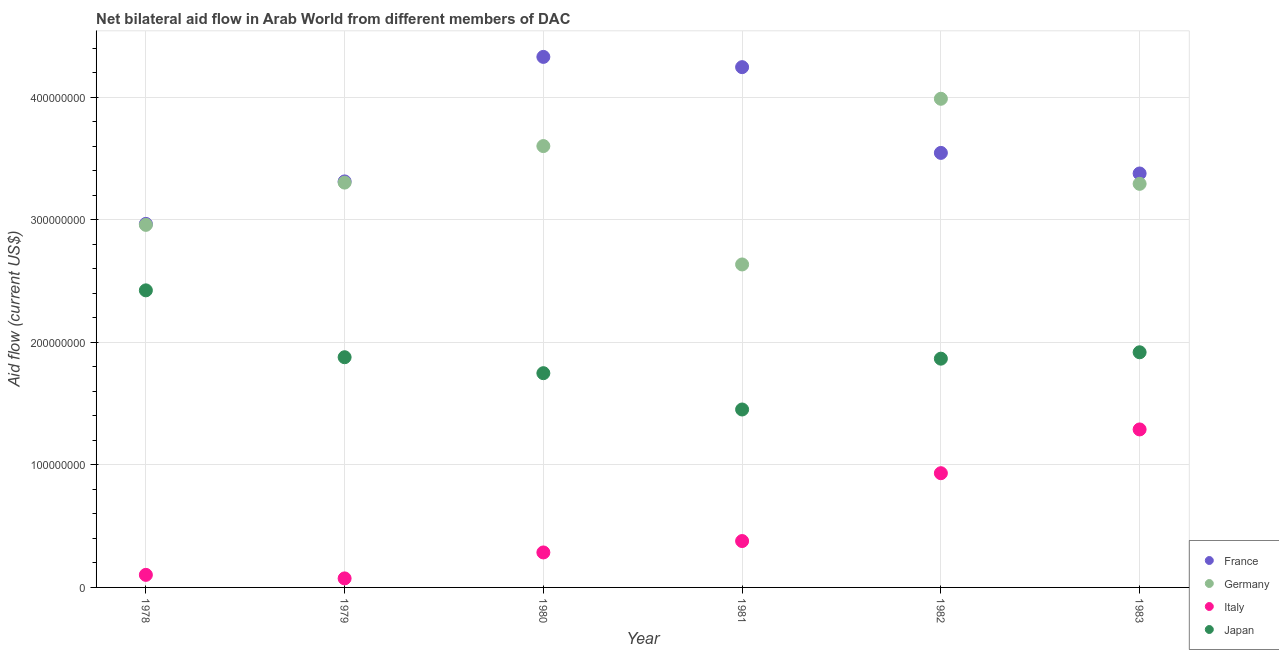How many different coloured dotlines are there?
Provide a short and direct response. 4. What is the amount of aid given by france in 1981?
Provide a succinct answer. 4.25e+08. Across all years, what is the maximum amount of aid given by france?
Your answer should be very brief. 4.33e+08. Across all years, what is the minimum amount of aid given by italy?
Your answer should be compact. 7.37e+06. In which year was the amount of aid given by germany maximum?
Keep it short and to the point. 1982. In which year was the amount of aid given by france minimum?
Provide a succinct answer. 1978. What is the total amount of aid given by japan in the graph?
Make the answer very short. 1.13e+09. What is the difference between the amount of aid given by france in 1978 and that in 1981?
Provide a succinct answer. -1.28e+08. What is the difference between the amount of aid given by japan in 1979 and the amount of aid given by germany in 1983?
Your response must be concise. -1.41e+08. What is the average amount of aid given by italy per year?
Make the answer very short. 5.10e+07. In the year 1980, what is the difference between the amount of aid given by japan and amount of aid given by italy?
Provide a succinct answer. 1.46e+08. In how many years, is the amount of aid given by japan greater than 340000000 US$?
Make the answer very short. 0. What is the ratio of the amount of aid given by italy in 1980 to that in 1982?
Make the answer very short. 0.31. Is the difference between the amount of aid given by italy in 1980 and 1982 greater than the difference between the amount of aid given by france in 1980 and 1982?
Ensure brevity in your answer.  No. What is the difference between the highest and the second highest amount of aid given by germany?
Give a very brief answer. 3.86e+07. What is the difference between the highest and the lowest amount of aid given by italy?
Ensure brevity in your answer.  1.22e+08. In how many years, is the amount of aid given by france greater than the average amount of aid given by france taken over all years?
Your answer should be very brief. 2. Is it the case that in every year, the sum of the amount of aid given by france and amount of aid given by germany is greater than the amount of aid given by italy?
Your response must be concise. Yes. Does the amount of aid given by japan monotonically increase over the years?
Offer a very short reply. No. Is the amount of aid given by italy strictly greater than the amount of aid given by germany over the years?
Your answer should be compact. No. How many dotlines are there?
Your response must be concise. 4. How many years are there in the graph?
Ensure brevity in your answer.  6. Are the values on the major ticks of Y-axis written in scientific E-notation?
Make the answer very short. No. How many legend labels are there?
Make the answer very short. 4. What is the title of the graph?
Give a very brief answer. Net bilateral aid flow in Arab World from different members of DAC. What is the label or title of the Y-axis?
Make the answer very short. Aid flow (current US$). What is the Aid flow (current US$) of France in 1978?
Make the answer very short. 2.97e+08. What is the Aid flow (current US$) of Germany in 1978?
Your answer should be compact. 2.96e+08. What is the Aid flow (current US$) of Italy in 1978?
Your answer should be compact. 1.02e+07. What is the Aid flow (current US$) in Japan in 1978?
Offer a terse response. 2.42e+08. What is the Aid flow (current US$) in France in 1979?
Give a very brief answer. 3.31e+08. What is the Aid flow (current US$) of Germany in 1979?
Your answer should be very brief. 3.30e+08. What is the Aid flow (current US$) of Italy in 1979?
Give a very brief answer. 7.37e+06. What is the Aid flow (current US$) in Japan in 1979?
Give a very brief answer. 1.88e+08. What is the Aid flow (current US$) in France in 1980?
Offer a terse response. 4.33e+08. What is the Aid flow (current US$) of Germany in 1980?
Your answer should be compact. 3.60e+08. What is the Aid flow (current US$) in Italy in 1980?
Your response must be concise. 2.85e+07. What is the Aid flow (current US$) of Japan in 1980?
Make the answer very short. 1.75e+08. What is the Aid flow (current US$) in France in 1981?
Provide a succinct answer. 4.25e+08. What is the Aid flow (current US$) of Germany in 1981?
Make the answer very short. 2.64e+08. What is the Aid flow (current US$) in Italy in 1981?
Provide a short and direct response. 3.78e+07. What is the Aid flow (current US$) in Japan in 1981?
Make the answer very short. 1.45e+08. What is the Aid flow (current US$) in France in 1982?
Your answer should be compact. 3.55e+08. What is the Aid flow (current US$) of Germany in 1982?
Ensure brevity in your answer.  3.99e+08. What is the Aid flow (current US$) of Italy in 1982?
Your response must be concise. 9.32e+07. What is the Aid flow (current US$) of Japan in 1982?
Your answer should be very brief. 1.87e+08. What is the Aid flow (current US$) of France in 1983?
Your answer should be very brief. 3.38e+08. What is the Aid flow (current US$) of Germany in 1983?
Offer a terse response. 3.29e+08. What is the Aid flow (current US$) of Italy in 1983?
Offer a very short reply. 1.29e+08. What is the Aid flow (current US$) in Japan in 1983?
Make the answer very short. 1.92e+08. Across all years, what is the maximum Aid flow (current US$) in France?
Offer a terse response. 4.33e+08. Across all years, what is the maximum Aid flow (current US$) of Germany?
Offer a very short reply. 3.99e+08. Across all years, what is the maximum Aid flow (current US$) of Italy?
Offer a very short reply. 1.29e+08. Across all years, what is the maximum Aid flow (current US$) of Japan?
Your answer should be compact. 2.42e+08. Across all years, what is the minimum Aid flow (current US$) in France?
Your response must be concise. 2.97e+08. Across all years, what is the minimum Aid flow (current US$) of Germany?
Your response must be concise. 2.64e+08. Across all years, what is the minimum Aid flow (current US$) of Italy?
Make the answer very short. 7.37e+06. Across all years, what is the minimum Aid flow (current US$) in Japan?
Provide a succinct answer. 1.45e+08. What is the total Aid flow (current US$) of France in the graph?
Provide a short and direct response. 2.18e+09. What is the total Aid flow (current US$) of Germany in the graph?
Make the answer very short. 1.98e+09. What is the total Aid flow (current US$) in Italy in the graph?
Give a very brief answer. 3.06e+08. What is the total Aid flow (current US$) in Japan in the graph?
Give a very brief answer. 1.13e+09. What is the difference between the Aid flow (current US$) of France in 1978 and that in 1979?
Provide a short and direct response. -3.47e+07. What is the difference between the Aid flow (current US$) in Germany in 1978 and that in 1979?
Ensure brevity in your answer.  -3.45e+07. What is the difference between the Aid flow (current US$) in Italy in 1978 and that in 1979?
Your answer should be very brief. 2.88e+06. What is the difference between the Aid flow (current US$) of Japan in 1978 and that in 1979?
Your answer should be compact. 5.46e+07. What is the difference between the Aid flow (current US$) of France in 1978 and that in 1980?
Offer a terse response. -1.36e+08. What is the difference between the Aid flow (current US$) of Germany in 1978 and that in 1980?
Offer a terse response. -6.43e+07. What is the difference between the Aid flow (current US$) of Italy in 1978 and that in 1980?
Offer a terse response. -1.83e+07. What is the difference between the Aid flow (current US$) of Japan in 1978 and that in 1980?
Your answer should be compact. 6.76e+07. What is the difference between the Aid flow (current US$) in France in 1978 and that in 1981?
Ensure brevity in your answer.  -1.28e+08. What is the difference between the Aid flow (current US$) in Germany in 1978 and that in 1981?
Offer a very short reply. 3.23e+07. What is the difference between the Aid flow (current US$) of Italy in 1978 and that in 1981?
Keep it short and to the point. -2.76e+07. What is the difference between the Aid flow (current US$) of Japan in 1978 and that in 1981?
Your response must be concise. 9.72e+07. What is the difference between the Aid flow (current US$) of France in 1978 and that in 1982?
Offer a very short reply. -5.79e+07. What is the difference between the Aid flow (current US$) of Germany in 1978 and that in 1982?
Provide a succinct answer. -1.03e+08. What is the difference between the Aid flow (current US$) in Italy in 1978 and that in 1982?
Keep it short and to the point. -8.30e+07. What is the difference between the Aid flow (current US$) of Japan in 1978 and that in 1982?
Keep it short and to the point. 5.57e+07. What is the difference between the Aid flow (current US$) of France in 1978 and that in 1983?
Offer a very short reply. -4.11e+07. What is the difference between the Aid flow (current US$) of Germany in 1978 and that in 1983?
Provide a short and direct response. -3.35e+07. What is the difference between the Aid flow (current US$) in Italy in 1978 and that in 1983?
Offer a terse response. -1.19e+08. What is the difference between the Aid flow (current US$) in Japan in 1978 and that in 1983?
Offer a very short reply. 5.05e+07. What is the difference between the Aid flow (current US$) in France in 1979 and that in 1980?
Provide a short and direct response. -1.02e+08. What is the difference between the Aid flow (current US$) in Germany in 1979 and that in 1980?
Make the answer very short. -2.98e+07. What is the difference between the Aid flow (current US$) of Italy in 1979 and that in 1980?
Provide a short and direct response. -2.12e+07. What is the difference between the Aid flow (current US$) in Japan in 1979 and that in 1980?
Give a very brief answer. 1.30e+07. What is the difference between the Aid flow (current US$) of France in 1979 and that in 1981?
Your response must be concise. -9.32e+07. What is the difference between the Aid flow (current US$) in Germany in 1979 and that in 1981?
Your response must be concise. 6.68e+07. What is the difference between the Aid flow (current US$) in Italy in 1979 and that in 1981?
Provide a short and direct response. -3.05e+07. What is the difference between the Aid flow (current US$) in Japan in 1979 and that in 1981?
Your answer should be very brief. 4.26e+07. What is the difference between the Aid flow (current US$) in France in 1979 and that in 1982?
Provide a short and direct response. -2.33e+07. What is the difference between the Aid flow (current US$) of Germany in 1979 and that in 1982?
Your answer should be compact. -6.84e+07. What is the difference between the Aid flow (current US$) of Italy in 1979 and that in 1982?
Give a very brief answer. -8.58e+07. What is the difference between the Aid flow (current US$) of Japan in 1979 and that in 1982?
Offer a very short reply. 1.18e+06. What is the difference between the Aid flow (current US$) in France in 1979 and that in 1983?
Give a very brief answer. -6.48e+06. What is the difference between the Aid flow (current US$) of Germany in 1979 and that in 1983?
Offer a very short reply. 1.01e+06. What is the difference between the Aid flow (current US$) of Italy in 1979 and that in 1983?
Provide a short and direct response. -1.22e+08. What is the difference between the Aid flow (current US$) of Japan in 1979 and that in 1983?
Your answer should be very brief. -4.03e+06. What is the difference between the Aid flow (current US$) in France in 1980 and that in 1981?
Make the answer very short. 8.36e+06. What is the difference between the Aid flow (current US$) of Germany in 1980 and that in 1981?
Keep it short and to the point. 9.66e+07. What is the difference between the Aid flow (current US$) of Italy in 1980 and that in 1981?
Keep it short and to the point. -9.30e+06. What is the difference between the Aid flow (current US$) of Japan in 1980 and that in 1981?
Make the answer very short. 2.96e+07. What is the difference between the Aid flow (current US$) in France in 1980 and that in 1982?
Your answer should be compact. 7.83e+07. What is the difference between the Aid flow (current US$) of Germany in 1980 and that in 1982?
Keep it short and to the point. -3.86e+07. What is the difference between the Aid flow (current US$) of Italy in 1980 and that in 1982?
Provide a succinct answer. -6.47e+07. What is the difference between the Aid flow (current US$) of Japan in 1980 and that in 1982?
Provide a succinct answer. -1.18e+07. What is the difference between the Aid flow (current US$) in France in 1980 and that in 1983?
Your answer should be very brief. 9.51e+07. What is the difference between the Aid flow (current US$) in Germany in 1980 and that in 1983?
Make the answer very short. 3.08e+07. What is the difference between the Aid flow (current US$) in Italy in 1980 and that in 1983?
Your response must be concise. -1.00e+08. What is the difference between the Aid flow (current US$) in Japan in 1980 and that in 1983?
Your answer should be compact. -1.70e+07. What is the difference between the Aid flow (current US$) in France in 1981 and that in 1982?
Offer a terse response. 7.00e+07. What is the difference between the Aid flow (current US$) of Germany in 1981 and that in 1982?
Offer a very short reply. -1.35e+08. What is the difference between the Aid flow (current US$) in Italy in 1981 and that in 1982?
Ensure brevity in your answer.  -5.54e+07. What is the difference between the Aid flow (current US$) of Japan in 1981 and that in 1982?
Offer a very short reply. -4.15e+07. What is the difference between the Aid flow (current US$) in France in 1981 and that in 1983?
Provide a short and direct response. 8.68e+07. What is the difference between the Aid flow (current US$) of Germany in 1981 and that in 1983?
Provide a short and direct response. -6.58e+07. What is the difference between the Aid flow (current US$) of Italy in 1981 and that in 1983?
Provide a succinct answer. -9.11e+07. What is the difference between the Aid flow (current US$) in Japan in 1981 and that in 1983?
Provide a succinct answer. -4.67e+07. What is the difference between the Aid flow (current US$) of France in 1982 and that in 1983?
Offer a very short reply. 1.68e+07. What is the difference between the Aid flow (current US$) in Germany in 1982 and that in 1983?
Your response must be concise. 6.94e+07. What is the difference between the Aid flow (current US$) in Italy in 1982 and that in 1983?
Offer a very short reply. -3.57e+07. What is the difference between the Aid flow (current US$) of Japan in 1982 and that in 1983?
Your response must be concise. -5.21e+06. What is the difference between the Aid flow (current US$) in France in 1978 and the Aid flow (current US$) in Germany in 1979?
Ensure brevity in your answer.  -3.37e+07. What is the difference between the Aid flow (current US$) of France in 1978 and the Aid flow (current US$) of Italy in 1979?
Offer a very short reply. 2.89e+08. What is the difference between the Aid flow (current US$) in France in 1978 and the Aid flow (current US$) in Japan in 1979?
Make the answer very short. 1.09e+08. What is the difference between the Aid flow (current US$) in Germany in 1978 and the Aid flow (current US$) in Italy in 1979?
Ensure brevity in your answer.  2.88e+08. What is the difference between the Aid flow (current US$) of Germany in 1978 and the Aid flow (current US$) of Japan in 1979?
Your answer should be very brief. 1.08e+08. What is the difference between the Aid flow (current US$) in Italy in 1978 and the Aid flow (current US$) in Japan in 1979?
Keep it short and to the point. -1.78e+08. What is the difference between the Aid flow (current US$) in France in 1978 and the Aid flow (current US$) in Germany in 1980?
Offer a very short reply. -6.35e+07. What is the difference between the Aid flow (current US$) in France in 1978 and the Aid flow (current US$) in Italy in 1980?
Give a very brief answer. 2.68e+08. What is the difference between the Aid flow (current US$) of France in 1978 and the Aid flow (current US$) of Japan in 1980?
Give a very brief answer. 1.22e+08. What is the difference between the Aid flow (current US$) of Germany in 1978 and the Aid flow (current US$) of Italy in 1980?
Your answer should be compact. 2.67e+08. What is the difference between the Aid flow (current US$) in Germany in 1978 and the Aid flow (current US$) in Japan in 1980?
Provide a short and direct response. 1.21e+08. What is the difference between the Aid flow (current US$) in Italy in 1978 and the Aid flow (current US$) in Japan in 1980?
Offer a very short reply. -1.65e+08. What is the difference between the Aid flow (current US$) of France in 1978 and the Aid flow (current US$) of Germany in 1981?
Provide a short and direct response. 3.31e+07. What is the difference between the Aid flow (current US$) in France in 1978 and the Aid flow (current US$) in Italy in 1981?
Keep it short and to the point. 2.59e+08. What is the difference between the Aid flow (current US$) in France in 1978 and the Aid flow (current US$) in Japan in 1981?
Make the answer very short. 1.51e+08. What is the difference between the Aid flow (current US$) of Germany in 1978 and the Aid flow (current US$) of Italy in 1981?
Your answer should be very brief. 2.58e+08. What is the difference between the Aid flow (current US$) in Germany in 1978 and the Aid flow (current US$) in Japan in 1981?
Ensure brevity in your answer.  1.51e+08. What is the difference between the Aid flow (current US$) of Italy in 1978 and the Aid flow (current US$) of Japan in 1981?
Keep it short and to the point. -1.35e+08. What is the difference between the Aid flow (current US$) of France in 1978 and the Aid flow (current US$) of Germany in 1982?
Ensure brevity in your answer.  -1.02e+08. What is the difference between the Aid flow (current US$) in France in 1978 and the Aid flow (current US$) in Italy in 1982?
Give a very brief answer. 2.03e+08. What is the difference between the Aid flow (current US$) in France in 1978 and the Aid flow (current US$) in Japan in 1982?
Your answer should be compact. 1.10e+08. What is the difference between the Aid flow (current US$) of Germany in 1978 and the Aid flow (current US$) of Italy in 1982?
Offer a very short reply. 2.03e+08. What is the difference between the Aid flow (current US$) in Germany in 1978 and the Aid flow (current US$) in Japan in 1982?
Keep it short and to the point. 1.09e+08. What is the difference between the Aid flow (current US$) in Italy in 1978 and the Aid flow (current US$) in Japan in 1982?
Give a very brief answer. -1.76e+08. What is the difference between the Aid flow (current US$) in France in 1978 and the Aid flow (current US$) in Germany in 1983?
Give a very brief answer. -3.27e+07. What is the difference between the Aid flow (current US$) in France in 1978 and the Aid flow (current US$) in Italy in 1983?
Offer a terse response. 1.68e+08. What is the difference between the Aid flow (current US$) of France in 1978 and the Aid flow (current US$) of Japan in 1983?
Make the answer very short. 1.05e+08. What is the difference between the Aid flow (current US$) of Germany in 1978 and the Aid flow (current US$) of Italy in 1983?
Give a very brief answer. 1.67e+08. What is the difference between the Aid flow (current US$) of Germany in 1978 and the Aid flow (current US$) of Japan in 1983?
Your answer should be compact. 1.04e+08. What is the difference between the Aid flow (current US$) of Italy in 1978 and the Aid flow (current US$) of Japan in 1983?
Give a very brief answer. -1.82e+08. What is the difference between the Aid flow (current US$) of France in 1979 and the Aid flow (current US$) of Germany in 1980?
Make the answer very short. -2.88e+07. What is the difference between the Aid flow (current US$) in France in 1979 and the Aid flow (current US$) in Italy in 1980?
Make the answer very short. 3.03e+08. What is the difference between the Aid flow (current US$) in France in 1979 and the Aid flow (current US$) in Japan in 1980?
Your answer should be very brief. 1.56e+08. What is the difference between the Aid flow (current US$) in Germany in 1979 and the Aid flow (current US$) in Italy in 1980?
Offer a terse response. 3.02e+08. What is the difference between the Aid flow (current US$) of Germany in 1979 and the Aid flow (current US$) of Japan in 1980?
Give a very brief answer. 1.56e+08. What is the difference between the Aid flow (current US$) of Italy in 1979 and the Aid flow (current US$) of Japan in 1980?
Your response must be concise. -1.67e+08. What is the difference between the Aid flow (current US$) of France in 1979 and the Aid flow (current US$) of Germany in 1981?
Offer a very short reply. 6.78e+07. What is the difference between the Aid flow (current US$) of France in 1979 and the Aid flow (current US$) of Italy in 1981?
Ensure brevity in your answer.  2.93e+08. What is the difference between the Aid flow (current US$) of France in 1979 and the Aid flow (current US$) of Japan in 1981?
Provide a succinct answer. 1.86e+08. What is the difference between the Aid flow (current US$) in Germany in 1979 and the Aid flow (current US$) in Italy in 1981?
Keep it short and to the point. 2.92e+08. What is the difference between the Aid flow (current US$) of Germany in 1979 and the Aid flow (current US$) of Japan in 1981?
Provide a succinct answer. 1.85e+08. What is the difference between the Aid flow (current US$) in Italy in 1979 and the Aid flow (current US$) in Japan in 1981?
Offer a terse response. -1.38e+08. What is the difference between the Aid flow (current US$) of France in 1979 and the Aid flow (current US$) of Germany in 1982?
Give a very brief answer. -6.74e+07. What is the difference between the Aid flow (current US$) of France in 1979 and the Aid flow (current US$) of Italy in 1982?
Your response must be concise. 2.38e+08. What is the difference between the Aid flow (current US$) in France in 1979 and the Aid flow (current US$) in Japan in 1982?
Your response must be concise. 1.45e+08. What is the difference between the Aid flow (current US$) of Germany in 1979 and the Aid flow (current US$) of Italy in 1982?
Your answer should be very brief. 2.37e+08. What is the difference between the Aid flow (current US$) of Germany in 1979 and the Aid flow (current US$) of Japan in 1982?
Keep it short and to the point. 1.44e+08. What is the difference between the Aid flow (current US$) in Italy in 1979 and the Aid flow (current US$) in Japan in 1982?
Your answer should be compact. -1.79e+08. What is the difference between the Aid flow (current US$) of France in 1979 and the Aid flow (current US$) of Germany in 1983?
Keep it short and to the point. 1.97e+06. What is the difference between the Aid flow (current US$) in France in 1979 and the Aid flow (current US$) in Italy in 1983?
Provide a short and direct response. 2.02e+08. What is the difference between the Aid flow (current US$) of France in 1979 and the Aid flow (current US$) of Japan in 1983?
Give a very brief answer. 1.39e+08. What is the difference between the Aid flow (current US$) in Germany in 1979 and the Aid flow (current US$) in Italy in 1983?
Give a very brief answer. 2.01e+08. What is the difference between the Aid flow (current US$) of Germany in 1979 and the Aid flow (current US$) of Japan in 1983?
Ensure brevity in your answer.  1.38e+08. What is the difference between the Aid flow (current US$) of Italy in 1979 and the Aid flow (current US$) of Japan in 1983?
Your answer should be very brief. -1.84e+08. What is the difference between the Aid flow (current US$) in France in 1980 and the Aid flow (current US$) in Germany in 1981?
Your answer should be very brief. 1.69e+08. What is the difference between the Aid flow (current US$) in France in 1980 and the Aid flow (current US$) in Italy in 1981?
Offer a terse response. 3.95e+08. What is the difference between the Aid flow (current US$) in France in 1980 and the Aid flow (current US$) in Japan in 1981?
Give a very brief answer. 2.88e+08. What is the difference between the Aid flow (current US$) in Germany in 1980 and the Aid flow (current US$) in Italy in 1981?
Your answer should be very brief. 3.22e+08. What is the difference between the Aid flow (current US$) in Germany in 1980 and the Aid flow (current US$) in Japan in 1981?
Offer a very short reply. 2.15e+08. What is the difference between the Aid flow (current US$) in Italy in 1980 and the Aid flow (current US$) in Japan in 1981?
Provide a short and direct response. -1.17e+08. What is the difference between the Aid flow (current US$) in France in 1980 and the Aid flow (current US$) in Germany in 1982?
Ensure brevity in your answer.  3.42e+07. What is the difference between the Aid flow (current US$) of France in 1980 and the Aid flow (current US$) of Italy in 1982?
Offer a terse response. 3.40e+08. What is the difference between the Aid flow (current US$) in France in 1980 and the Aid flow (current US$) in Japan in 1982?
Your answer should be very brief. 2.46e+08. What is the difference between the Aid flow (current US$) in Germany in 1980 and the Aid flow (current US$) in Italy in 1982?
Keep it short and to the point. 2.67e+08. What is the difference between the Aid flow (current US$) in Germany in 1980 and the Aid flow (current US$) in Japan in 1982?
Give a very brief answer. 1.73e+08. What is the difference between the Aid flow (current US$) in Italy in 1980 and the Aid flow (current US$) in Japan in 1982?
Your response must be concise. -1.58e+08. What is the difference between the Aid flow (current US$) in France in 1980 and the Aid flow (current US$) in Germany in 1983?
Offer a terse response. 1.04e+08. What is the difference between the Aid flow (current US$) in France in 1980 and the Aid flow (current US$) in Italy in 1983?
Provide a short and direct response. 3.04e+08. What is the difference between the Aid flow (current US$) in France in 1980 and the Aid flow (current US$) in Japan in 1983?
Make the answer very short. 2.41e+08. What is the difference between the Aid flow (current US$) of Germany in 1980 and the Aid flow (current US$) of Italy in 1983?
Ensure brevity in your answer.  2.31e+08. What is the difference between the Aid flow (current US$) of Germany in 1980 and the Aid flow (current US$) of Japan in 1983?
Provide a succinct answer. 1.68e+08. What is the difference between the Aid flow (current US$) in Italy in 1980 and the Aid flow (current US$) in Japan in 1983?
Keep it short and to the point. -1.63e+08. What is the difference between the Aid flow (current US$) in France in 1981 and the Aid flow (current US$) in Germany in 1982?
Make the answer very short. 2.58e+07. What is the difference between the Aid flow (current US$) in France in 1981 and the Aid flow (current US$) in Italy in 1982?
Offer a terse response. 3.31e+08. What is the difference between the Aid flow (current US$) of France in 1981 and the Aid flow (current US$) of Japan in 1982?
Give a very brief answer. 2.38e+08. What is the difference between the Aid flow (current US$) in Germany in 1981 and the Aid flow (current US$) in Italy in 1982?
Offer a very short reply. 1.70e+08. What is the difference between the Aid flow (current US$) of Germany in 1981 and the Aid flow (current US$) of Japan in 1982?
Your answer should be compact. 7.69e+07. What is the difference between the Aid flow (current US$) in Italy in 1981 and the Aid flow (current US$) in Japan in 1982?
Offer a very short reply. -1.49e+08. What is the difference between the Aid flow (current US$) in France in 1981 and the Aid flow (current US$) in Germany in 1983?
Offer a terse response. 9.52e+07. What is the difference between the Aid flow (current US$) of France in 1981 and the Aid flow (current US$) of Italy in 1983?
Your answer should be compact. 2.96e+08. What is the difference between the Aid flow (current US$) in France in 1981 and the Aid flow (current US$) in Japan in 1983?
Provide a short and direct response. 2.33e+08. What is the difference between the Aid flow (current US$) in Germany in 1981 and the Aid flow (current US$) in Italy in 1983?
Your answer should be compact. 1.35e+08. What is the difference between the Aid flow (current US$) in Germany in 1981 and the Aid flow (current US$) in Japan in 1983?
Your response must be concise. 7.17e+07. What is the difference between the Aid flow (current US$) in Italy in 1981 and the Aid flow (current US$) in Japan in 1983?
Provide a succinct answer. -1.54e+08. What is the difference between the Aid flow (current US$) in France in 1982 and the Aid flow (current US$) in Germany in 1983?
Provide a succinct answer. 2.52e+07. What is the difference between the Aid flow (current US$) in France in 1982 and the Aid flow (current US$) in Italy in 1983?
Offer a very short reply. 2.26e+08. What is the difference between the Aid flow (current US$) of France in 1982 and the Aid flow (current US$) of Japan in 1983?
Make the answer very short. 1.63e+08. What is the difference between the Aid flow (current US$) of Germany in 1982 and the Aid flow (current US$) of Italy in 1983?
Provide a succinct answer. 2.70e+08. What is the difference between the Aid flow (current US$) in Germany in 1982 and the Aid flow (current US$) in Japan in 1983?
Offer a very short reply. 2.07e+08. What is the difference between the Aid flow (current US$) of Italy in 1982 and the Aid flow (current US$) of Japan in 1983?
Your answer should be compact. -9.87e+07. What is the average Aid flow (current US$) of France per year?
Offer a terse response. 3.63e+08. What is the average Aid flow (current US$) in Germany per year?
Provide a succinct answer. 3.30e+08. What is the average Aid flow (current US$) in Italy per year?
Provide a succinct answer. 5.10e+07. What is the average Aid flow (current US$) of Japan per year?
Keep it short and to the point. 1.88e+08. In the year 1978, what is the difference between the Aid flow (current US$) in France and Aid flow (current US$) in Germany?
Make the answer very short. 7.90e+05. In the year 1978, what is the difference between the Aid flow (current US$) in France and Aid flow (current US$) in Italy?
Provide a short and direct response. 2.86e+08. In the year 1978, what is the difference between the Aid flow (current US$) of France and Aid flow (current US$) of Japan?
Give a very brief answer. 5.42e+07. In the year 1978, what is the difference between the Aid flow (current US$) of Germany and Aid flow (current US$) of Italy?
Your answer should be compact. 2.86e+08. In the year 1978, what is the difference between the Aid flow (current US$) of Germany and Aid flow (current US$) of Japan?
Offer a very short reply. 5.34e+07. In the year 1978, what is the difference between the Aid flow (current US$) in Italy and Aid flow (current US$) in Japan?
Offer a terse response. -2.32e+08. In the year 1979, what is the difference between the Aid flow (current US$) of France and Aid flow (current US$) of Germany?
Provide a short and direct response. 9.60e+05. In the year 1979, what is the difference between the Aid flow (current US$) in France and Aid flow (current US$) in Italy?
Your answer should be compact. 3.24e+08. In the year 1979, what is the difference between the Aid flow (current US$) of France and Aid flow (current US$) of Japan?
Keep it short and to the point. 1.43e+08. In the year 1979, what is the difference between the Aid flow (current US$) in Germany and Aid flow (current US$) in Italy?
Provide a short and direct response. 3.23e+08. In the year 1979, what is the difference between the Aid flow (current US$) in Germany and Aid flow (current US$) in Japan?
Ensure brevity in your answer.  1.42e+08. In the year 1979, what is the difference between the Aid flow (current US$) of Italy and Aid flow (current US$) of Japan?
Make the answer very short. -1.80e+08. In the year 1980, what is the difference between the Aid flow (current US$) of France and Aid flow (current US$) of Germany?
Keep it short and to the point. 7.28e+07. In the year 1980, what is the difference between the Aid flow (current US$) of France and Aid flow (current US$) of Italy?
Offer a terse response. 4.04e+08. In the year 1980, what is the difference between the Aid flow (current US$) of France and Aid flow (current US$) of Japan?
Provide a succinct answer. 2.58e+08. In the year 1980, what is the difference between the Aid flow (current US$) of Germany and Aid flow (current US$) of Italy?
Your response must be concise. 3.32e+08. In the year 1980, what is the difference between the Aid flow (current US$) of Germany and Aid flow (current US$) of Japan?
Provide a succinct answer. 1.85e+08. In the year 1980, what is the difference between the Aid flow (current US$) in Italy and Aid flow (current US$) in Japan?
Your answer should be very brief. -1.46e+08. In the year 1981, what is the difference between the Aid flow (current US$) in France and Aid flow (current US$) in Germany?
Your answer should be compact. 1.61e+08. In the year 1981, what is the difference between the Aid flow (current US$) in France and Aid flow (current US$) in Italy?
Provide a succinct answer. 3.87e+08. In the year 1981, what is the difference between the Aid flow (current US$) of France and Aid flow (current US$) of Japan?
Provide a succinct answer. 2.79e+08. In the year 1981, what is the difference between the Aid flow (current US$) of Germany and Aid flow (current US$) of Italy?
Make the answer very short. 2.26e+08. In the year 1981, what is the difference between the Aid flow (current US$) of Germany and Aid flow (current US$) of Japan?
Ensure brevity in your answer.  1.18e+08. In the year 1981, what is the difference between the Aid flow (current US$) of Italy and Aid flow (current US$) of Japan?
Offer a very short reply. -1.07e+08. In the year 1982, what is the difference between the Aid flow (current US$) of France and Aid flow (current US$) of Germany?
Offer a very short reply. -4.42e+07. In the year 1982, what is the difference between the Aid flow (current US$) in France and Aid flow (current US$) in Italy?
Provide a succinct answer. 2.61e+08. In the year 1982, what is the difference between the Aid flow (current US$) of France and Aid flow (current US$) of Japan?
Make the answer very short. 1.68e+08. In the year 1982, what is the difference between the Aid flow (current US$) in Germany and Aid flow (current US$) in Italy?
Make the answer very short. 3.06e+08. In the year 1982, what is the difference between the Aid flow (current US$) of Germany and Aid flow (current US$) of Japan?
Provide a short and direct response. 2.12e+08. In the year 1982, what is the difference between the Aid flow (current US$) of Italy and Aid flow (current US$) of Japan?
Offer a terse response. -9.34e+07. In the year 1983, what is the difference between the Aid flow (current US$) in France and Aid flow (current US$) in Germany?
Offer a very short reply. 8.45e+06. In the year 1983, what is the difference between the Aid flow (current US$) of France and Aid flow (current US$) of Italy?
Provide a short and direct response. 2.09e+08. In the year 1983, what is the difference between the Aid flow (current US$) of France and Aid flow (current US$) of Japan?
Keep it short and to the point. 1.46e+08. In the year 1983, what is the difference between the Aid flow (current US$) of Germany and Aid flow (current US$) of Italy?
Offer a very short reply. 2.00e+08. In the year 1983, what is the difference between the Aid flow (current US$) of Germany and Aid flow (current US$) of Japan?
Give a very brief answer. 1.37e+08. In the year 1983, what is the difference between the Aid flow (current US$) of Italy and Aid flow (current US$) of Japan?
Keep it short and to the point. -6.30e+07. What is the ratio of the Aid flow (current US$) of France in 1978 to that in 1979?
Your answer should be compact. 0.9. What is the ratio of the Aid flow (current US$) of Germany in 1978 to that in 1979?
Offer a terse response. 0.9. What is the ratio of the Aid flow (current US$) in Italy in 1978 to that in 1979?
Make the answer very short. 1.39. What is the ratio of the Aid flow (current US$) in Japan in 1978 to that in 1979?
Ensure brevity in your answer.  1.29. What is the ratio of the Aid flow (current US$) in France in 1978 to that in 1980?
Your answer should be very brief. 0.69. What is the ratio of the Aid flow (current US$) in Germany in 1978 to that in 1980?
Offer a terse response. 0.82. What is the ratio of the Aid flow (current US$) of Italy in 1978 to that in 1980?
Your response must be concise. 0.36. What is the ratio of the Aid flow (current US$) of Japan in 1978 to that in 1980?
Offer a terse response. 1.39. What is the ratio of the Aid flow (current US$) in France in 1978 to that in 1981?
Offer a very short reply. 0.7. What is the ratio of the Aid flow (current US$) in Germany in 1978 to that in 1981?
Provide a short and direct response. 1.12. What is the ratio of the Aid flow (current US$) in Italy in 1978 to that in 1981?
Keep it short and to the point. 0.27. What is the ratio of the Aid flow (current US$) of Japan in 1978 to that in 1981?
Provide a succinct answer. 1.67. What is the ratio of the Aid flow (current US$) of France in 1978 to that in 1982?
Ensure brevity in your answer.  0.84. What is the ratio of the Aid flow (current US$) of Germany in 1978 to that in 1982?
Your response must be concise. 0.74. What is the ratio of the Aid flow (current US$) in Italy in 1978 to that in 1982?
Give a very brief answer. 0.11. What is the ratio of the Aid flow (current US$) in Japan in 1978 to that in 1982?
Provide a succinct answer. 1.3. What is the ratio of the Aid flow (current US$) in France in 1978 to that in 1983?
Offer a very short reply. 0.88. What is the ratio of the Aid flow (current US$) of Germany in 1978 to that in 1983?
Your answer should be compact. 0.9. What is the ratio of the Aid flow (current US$) of Italy in 1978 to that in 1983?
Your response must be concise. 0.08. What is the ratio of the Aid flow (current US$) of Japan in 1978 to that in 1983?
Ensure brevity in your answer.  1.26. What is the ratio of the Aid flow (current US$) of France in 1979 to that in 1980?
Give a very brief answer. 0.77. What is the ratio of the Aid flow (current US$) in Germany in 1979 to that in 1980?
Your answer should be compact. 0.92. What is the ratio of the Aid flow (current US$) in Italy in 1979 to that in 1980?
Give a very brief answer. 0.26. What is the ratio of the Aid flow (current US$) of Japan in 1979 to that in 1980?
Give a very brief answer. 1.07. What is the ratio of the Aid flow (current US$) of France in 1979 to that in 1981?
Your answer should be compact. 0.78. What is the ratio of the Aid flow (current US$) of Germany in 1979 to that in 1981?
Your answer should be very brief. 1.25. What is the ratio of the Aid flow (current US$) of Italy in 1979 to that in 1981?
Ensure brevity in your answer.  0.19. What is the ratio of the Aid flow (current US$) in Japan in 1979 to that in 1981?
Your answer should be very brief. 1.29. What is the ratio of the Aid flow (current US$) in France in 1979 to that in 1982?
Provide a short and direct response. 0.93. What is the ratio of the Aid flow (current US$) in Germany in 1979 to that in 1982?
Provide a succinct answer. 0.83. What is the ratio of the Aid flow (current US$) in Italy in 1979 to that in 1982?
Make the answer very short. 0.08. What is the ratio of the Aid flow (current US$) in Japan in 1979 to that in 1982?
Provide a succinct answer. 1.01. What is the ratio of the Aid flow (current US$) of France in 1979 to that in 1983?
Ensure brevity in your answer.  0.98. What is the ratio of the Aid flow (current US$) of Italy in 1979 to that in 1983?
Ensure brevity in your answer.  0.06. What is the ratio of the Aid flow (current US$) in Japan in 1979 to that in 1983?
Provide a succinct answer. 0.98. What is the ratio of the Aid flow (current US$) of France in 1980 to that in 1981?
Your answer should be very brief. 1.02. What is the ratio of the Aid flow (current US$) of Germany in 1980 to that in 1981?
Your response must be concise. 1.37. What is the ratio of the Aid flow (current US$) of Italy in 1980 to that in 1981?
Offer a very short reply. 0.75. What is the ratio of the Aid flow (current US$) of Japan in 1980 to that in 1981?
Make the answer very short. 1.2. What is the ratio of the Aid flow (current US$) of France in 1980 to that in 1982?
Your answer should be compact. 1.22. What is the ratio of the Aid flow (current US$) in Germany in 1980 to that in 1982?
Give a very brief answer. 0.9. What is the ratio of the Aid flow (current US$) of Italy in 1980 to that in 1982?
Provide a succinct answer. 0.31. What is the ratio of the Aid flow (current US$) in Japan in 1980 to that in 1982?
Provide a short and direct response. 0.94. What is the ratio of the Aid flow (current US$) in France in 1980 to that in 1983?
Offer a very short reply. 1.28. What is the ratio of the Aid flow (current US$) of Germany in 1980 to that in 1983?
Provide a short and direct response. 1.09. What is the ratio of the Aid flow (current US$) in Italy in 1980 to that in 1983?
Ensure brevity in your answer.  0.22. What is the ratio of the Aid flow (current US$) of Japan in 1980 to that in 1983?
Offer a terse response. 0.91. What is the ratio of the Aid flow (current US$) in France in 1981 to that in 1982?
Keep it short and to the point. 1.2. What is the ratio of the Aid flow (current US$) in Germany in 1981 to that in 1982?
Make the answer very short. 0.66. What is the ratio of the Aid flow (current US$) of Italy in 1981 to that in 1982?
Give a very brief answer. 0.41. What is the ratio of the Aid flow (current US$) of Japan in 1981 to that in 1982?
Keep it short and to the point. 0.78. What is the ratio of the Aid flow (current US$) in France in 1981 to that in 1983?
Your answer should be very brief. 1.26. What is the ratio of the Aid flow (current US$) of Germany in 1981 to that in 1983?
Provide a succinct answer. 0.8. What is the ratio of the Aid flow (current US$) in Italy in 1981 to that in 1983?
Ensure brevity in your answer.  0.29. What is the ratio of the Aid flow (current US$) in Japan in 1981 to that in 1983?
Your response must be concise. 0.76. What is the ratio of the Aid flow (current US$) of France in 1982 to that in 1983?
Give a very brief answer. 1.05. What is the ratio of the Aid flow (current US$) in Germany in 1982 to that in 1983?
Offer a terse response. 1.21. What is the ratio of the Aid flow (current US$) in Italy in 1982 to that in 1983?
Your answer should be very brief. 0.72. What is the ratio of the Aid flow (current US$) in Japan in 1982 to that in 1983?
Provide a short and direct response. 0.97. What is the difference between the highest and the second highest Aid flow (current US$) of France?
Provide a short and direct response. 8.36e+06. What is the difference between the highest and the second highest Aid flow (current US$) in Germany?
Give a very brief answer. 3.86e+07. What is the difference between the highest and the second highest Aid flow (current US$) in Italy?
Make the answer very short. 3.57e+07. What is the difference between the highest and the second highest Aid flow (current US$) in Japan?
Make the answer very short. 5.05e+07. What is the difference between the highest and the lowest Aid flow (current US$) in France?
Offer a terse response. 1.36e+08. What is the difference between the highest and the lowest Aid flow (current US$) in Germany?
Ensure brevity in your answer.  1.35e+08. What is the difference between the highest and the lowest Aid flow (current US$) of Italy?
Offer a very short reply. 1.22e+08. What is the difference between the highest and the lowest Aid flow (current US$) in Japan?
Provide a succinct answer. 9.72e+07. 